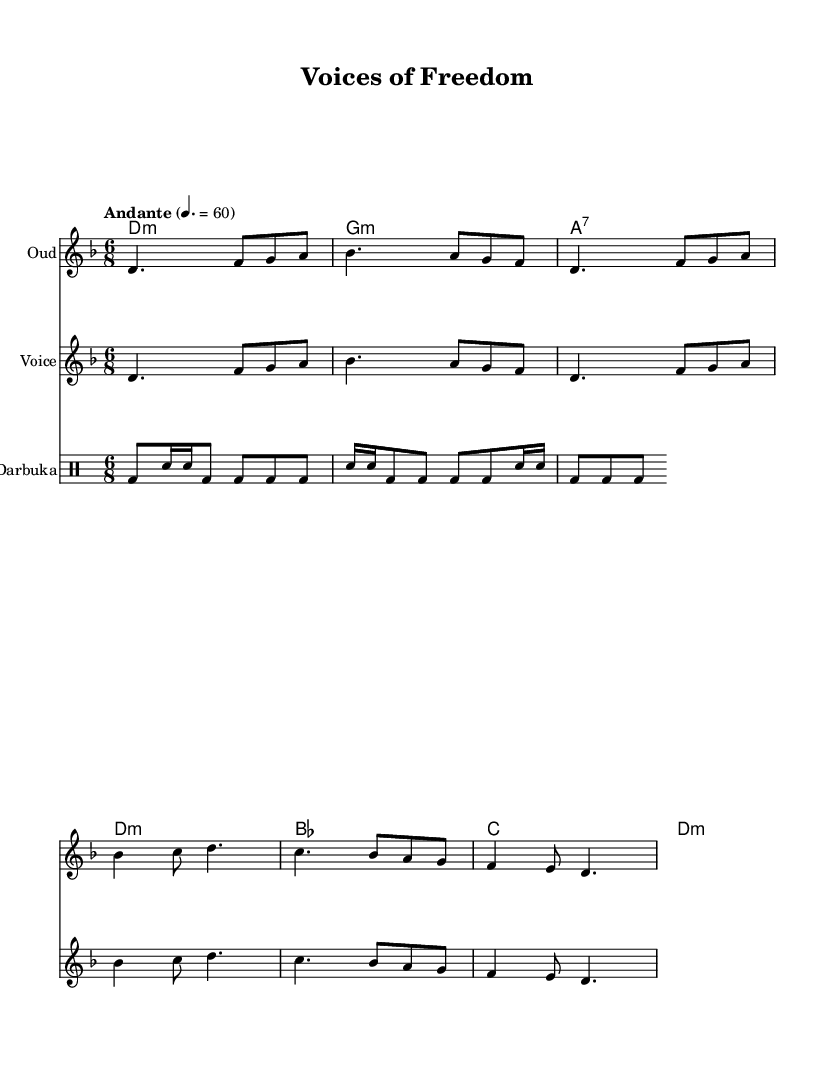What is the key signature of this music? The key signature is D minor, which includes one flat (B flat).
Answer: D minor What is the time signature of the piece? The time signature is 6/8, which indicates there are six eighth-note beats in each measure.
Answer: 6/8 What is the tempo marking for this score? The tempo marking is "Andante," which means a moderately slow tempo, approximately 60 beats per minute.
Answer: Andante What is the name of the instrument labeled in the first staff? The instrument is labeled "Oud," which is a traditional Middle Eastern string instrument often used in folk music.
Answer: Oud How many measures are in the vocal part? There are six measures in the vocal part, as seen from the notation in the staff.
Answer: Six What type of musical texture is used in this piece? The piece has a homophonic texture, as the melody (voice and oud) is supported by harmonic accompaniment (chords and darbuka).
Answer: Homophonic What themes are reflected in the lyrics of this piece? The lyrics reflect themes of unity, freedom, and social change, which are common in politically charged folk music.
Answer: Unity, freedom, social change 